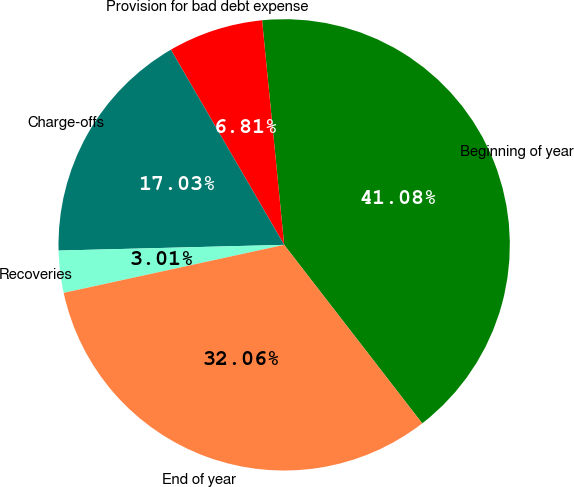Convert chart. <chart><loc_0><loc_0><loc_500><loc_500><pie_chart><fcel>Beginning of year<fcel>Provision for bad debt expense<fcel>Charge-offs<fcel>Recoveries<fcel>End of year<nl><fcel>41.08%<fcel>6.81%<fcel>17.03%<fcel>3.01%<fcel>32.06%<nl></chart> 